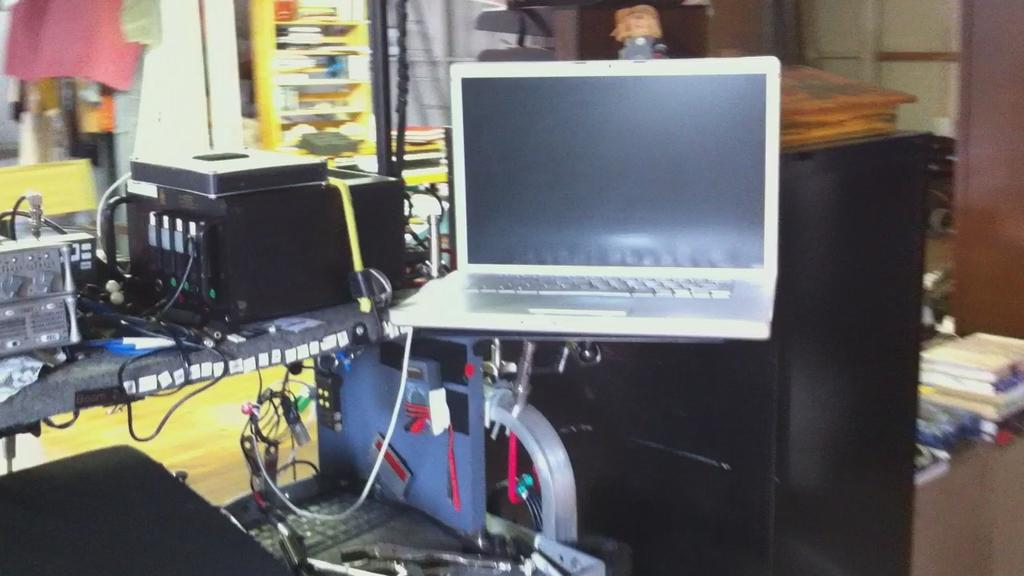What electronic device is visible in the image? There is a laptop in the image. What type of items can be seen near the laptop? There are books and a keyboard visible in the image. What type of furniture is present in the image? There are tables in the image. What else can be seen connected to the laptop? Cables are visible in the image. Are there any other objects present in the image besides the laptop, books, tables, and cables? Yes, there are other objects present in the image. What type of crops are being grown on the farm in the image? There is no farm or crops present in the image; it features a laptop, books, tables, and cables. What degree is the person in the image pursuing? There is no person present in the image, so it is not possible to determine what degree they might be pursuing. 